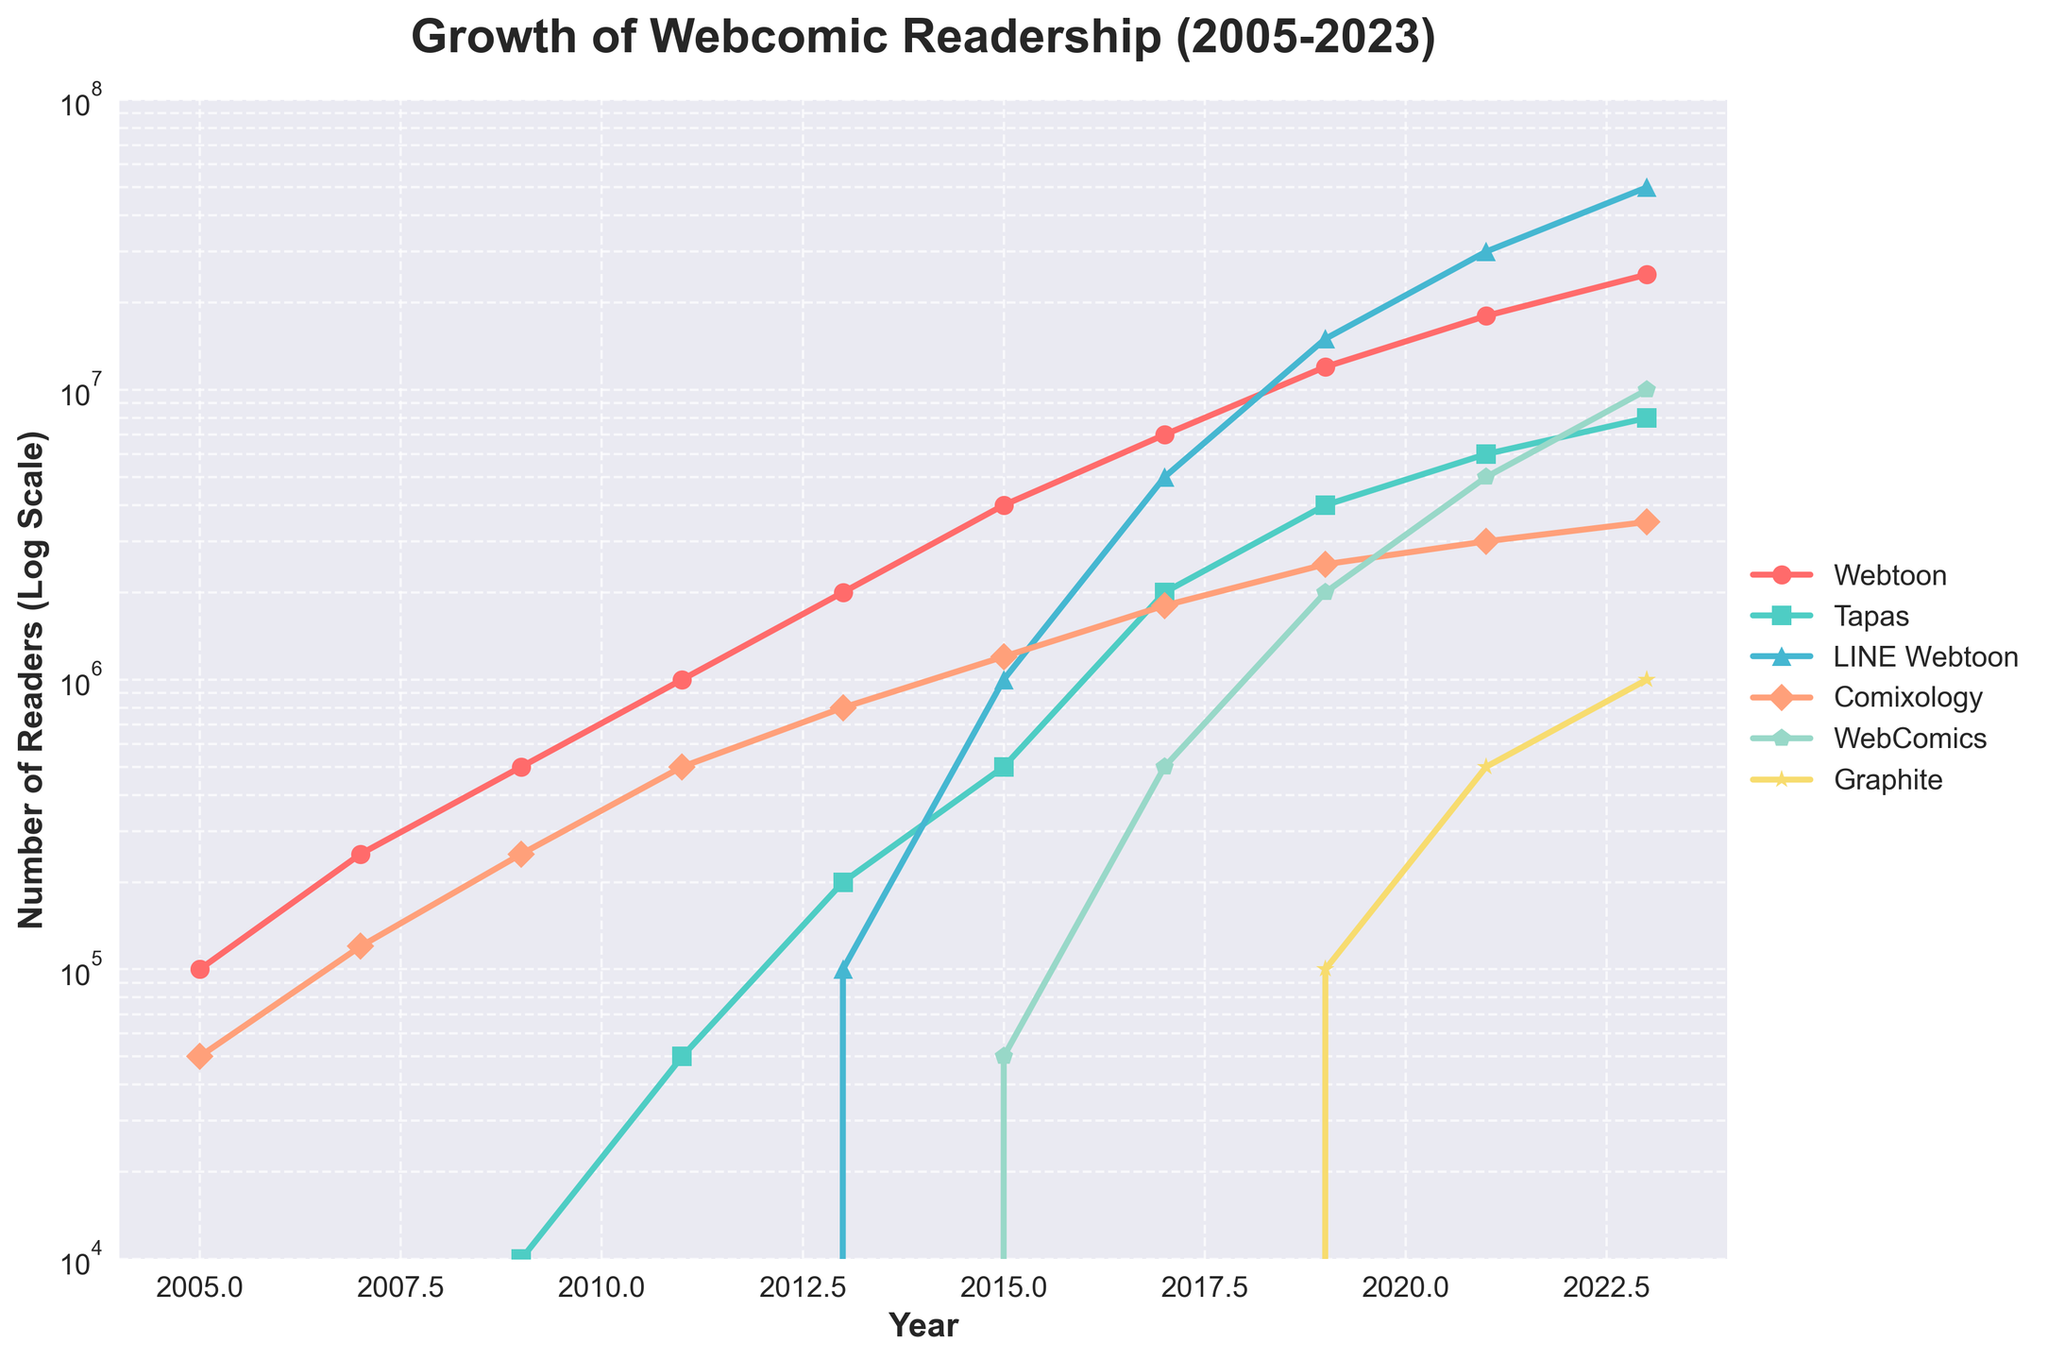What platform had the highest number of readers in 2023? According to the plot, LINE Webtoon had the highest number of readers in 2023 as it reached the highest point on the y-axis among all platforms.
Answer: LINE Webtoon Which platform had the steepest growth in readers between 2019 and 2023? LINE Webtoon showed the steepest growth between 2019 and 2023 as indicated by the sharp upward slope in that period.
Answer: LINE Webtoon How many readers did Tapas have in 2015 and how many more did it have by 2021? Tapas had 500,000 readers in 2015 and increased to 6,000,000 by 2021. The difference is 6,000,000 - 500,000 = 5,500,000.
Answer: 5,500,000 Which platform had the lowest readership in 2017 and how many readers were there? Graphite had the lowest readership in 2017 with 0 readers, as it didn't appear on the plot until later years.
Answer: Graphite What is the average readership of Webtoon from 2005 to 2023? Sum of readership values for Webtoon (from 2005 to 2023) is 100,000 + 250,000 + 500,000 + 1,000,000 + 2,000,000 + 4,000,000 + 7,000,000 + 12,000,000 + 18,000,000 + 25,000,000 = 70,850,000. Dividing by the number of data points (10), the average is 70,850,000 / 10 = 7,085,000.
Answer: 7,085,000 Between which two consecutive years did Comixology experience the highest growth in readership? Comixology had the highest growth between 2017 and 2019, going from 1,800,000 to 2,500,000 readers (a difference of 700,000 readers).
Answer: 2017-2019 Which platform shows an exponential growth trend between 2017 and 2021? WebComics shows an exponential growth trend between 2017 and 2021, as evident from the steep and continuously increasing curve.
Answer: WebComics Compare the readership of WebComics and Graphite in 2023. Which one is higher and by how much? In 2023, WebComics had 10,000,000 readers whereas Graphite had 1,000,000 readers. The difference is 10,000,000 - 1,000,000 = 9,000,000. Thus, WebComics had a higher readership by 9,000,000.
Answer: WebComics by 9,000,000 What was the overall trend for the readership of Webtoon from 2005 to 2023? The readership of Webtoon shows a consistently increasing trend from 2005 to 2023, indicating a steady rise in popularity over the years.
Answer: Increasing trend How did the readership of LINE Webtoon change between 2015 and 2019? The readership of LINE Webtoon increased from 1,000,000 in 2015 to 15,000,000 in 2019, showing significant growth of 14,000,000 readers over this period.
Answer: Increased by 14,000,000 